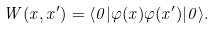<formula> <loc_0><loc_0><loc_500><loc_500>W ( x , x ^ { \prime } ) = \langle 0 | \varphi ( x ) \varphi ( x ^ { \prime } ) | 0 \rangle .</formula> 